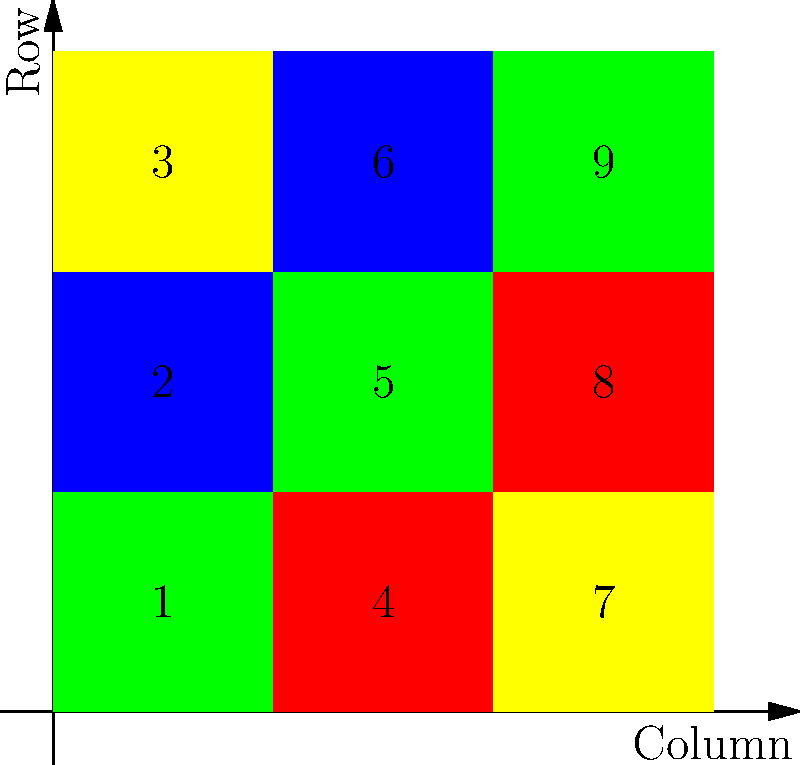Given the visual representation of a 3x3 matrix used for data encryption, where each number corresponds to a specific color (1-Red, 2-Green, 3-Blue, 4-Yellow), what is the sum of the elements in the main diagonal? How would this sum be used in a simple encryption scheme? To solve this problem, we need to follow these steps:

1. Identify the main diagonal elements:
   - The main diagonal consists of elements where the row index equals the column index.
   - In this 3x3 matrix, the main diagonal elements are:
     * Top-left: 1 (Red)
     * Center: 5 (Yellow)
     * Bottom-right: 9 (Yellow)

2. Sum the main diagonal elements:
   $1 + 5 + 9 = 15$

3. Understand how this sum could be used in a simple encryption scheme:
   - The sum (15) could be used as a key or seed for a pseudorandom number generator.
   - In a simple substitution cipher, each character in the plaintext could be shifted by a number of positions equal to the corresponding element in the matrix, cycling through the main diagonal sum.
   - For example, if encrypting the word "HELLO":
     * H: shifted by 1 (first diagonal element)
     * E: shifted by 5 (second diagonal element)
     * L: shifted by 9 (third diagonal element)
     * L: shifted by 1 (cycling back to the first element)
     * O: shifted by 5 (second element)

This method provides a basic level of encryption that utilizes the visual representation of the matrix while incorporating the sum of the main diagonal as a key component of the encryption process.
Answer: 15; used as key for substitution cipher 